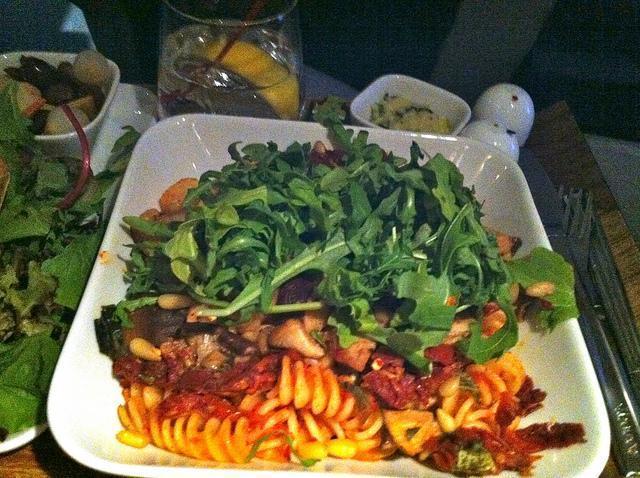How many different kinds of lettuce on the plate?
Give a very brief answer. 1. How many bowls are in the photo?
Give a very brief answer. 4. 